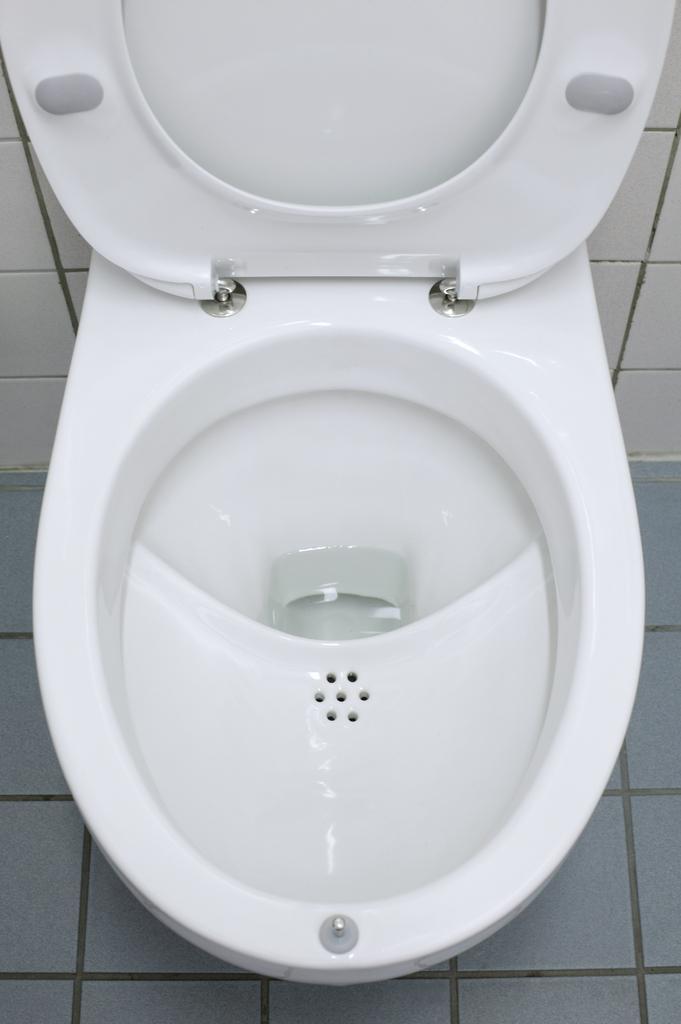Could you give a brief overview of what you see in this image? In the image there is a toilet seat and around the toilet seat there are tiles in the washroom. 